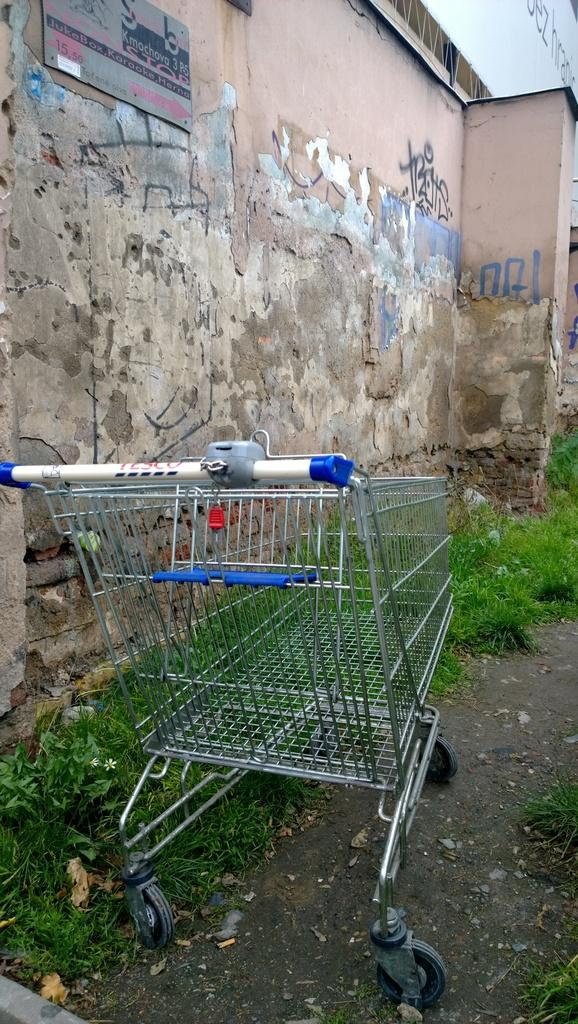What is the main object in the image? There is a trolley in the image. Where is the trolley located? The trolley is on the land. What type of vegetation is present near the trolley? Grass is present beside the trolley. What is the background feature following the trolley? There is a wall following the trolley. What is the texture of the lumber in the image? There is no lumber present in the image; it only features a trolley, grass, and a wall. 